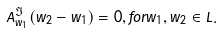<formula> <loc_0><loc_0><loc_500><loc_500>A ^ { \Im } _ { w _ { 1 } } ( w _ { 2 } - w _ { 1 } ) = 0 , f o r w _ { 1 } , w _ { 2 } \in L .</formula> 